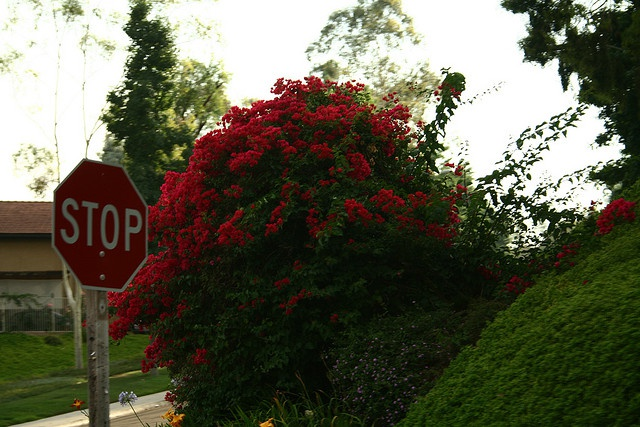Describe the objects in this image and their specific colors. I can see a stop sign in white, maroon, gray, and black tones in this image. 